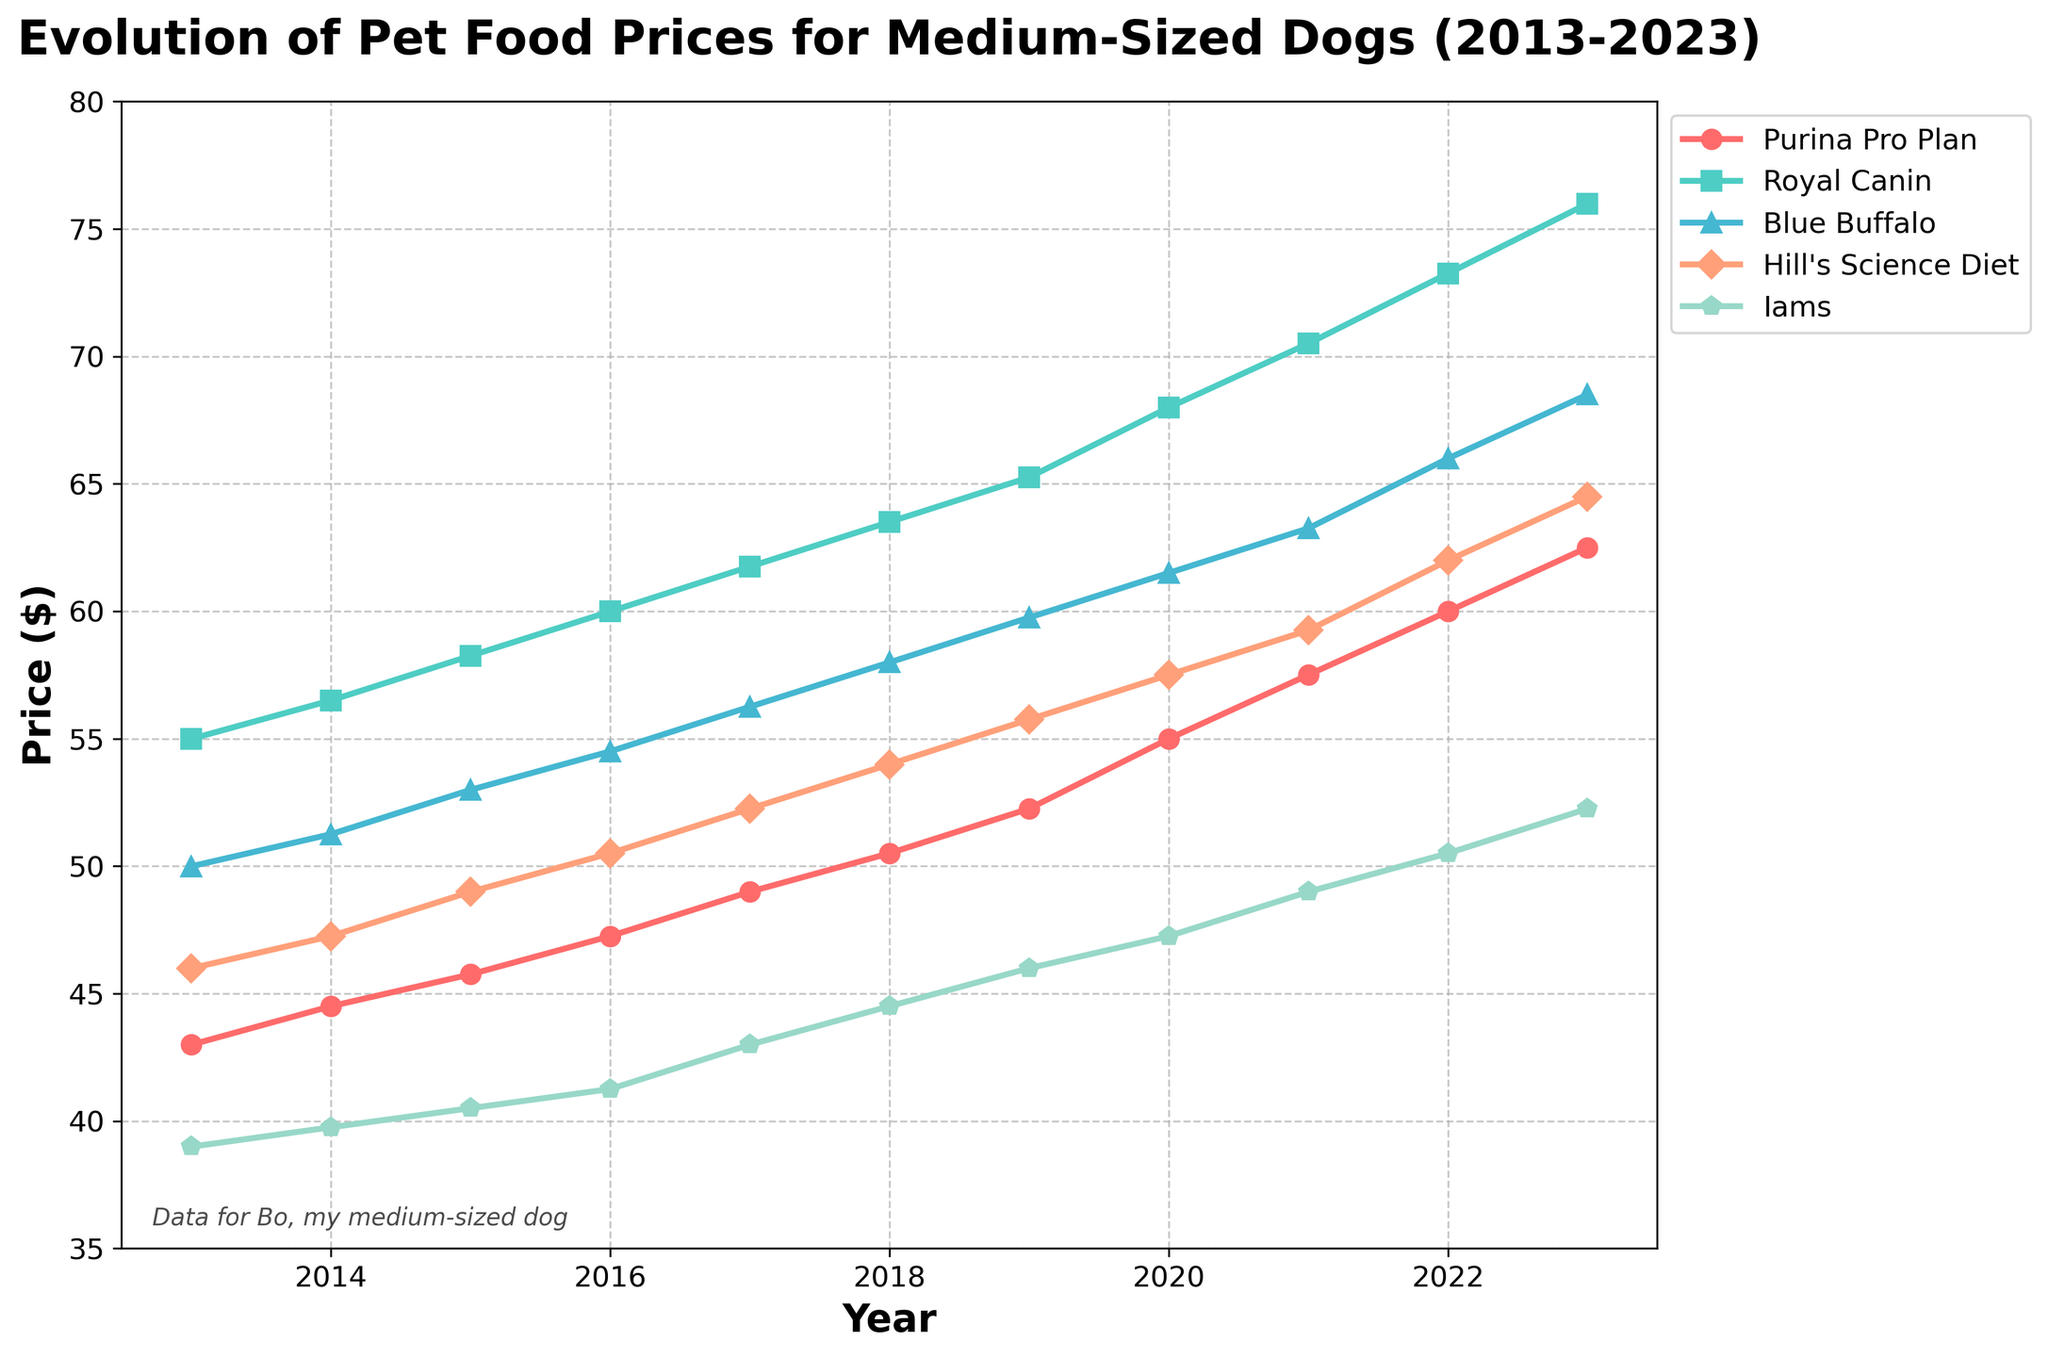What is the overall trend of pet food prices for medium-sized dogs from 2013 to 2023? The overall trend shows a steady increase in the prices of all the pet food brands over the decade. Every line on the chart slopes upward from left to right, indicating that prices have generally risen every year.
Answer: Steady increase Which pet food brand was the most expensive in 2013? To find the most expensive brand in 2013, look at the data points for 2013 on the left side of the chart. The highest data point for 2013 corresponds to Royal Canin.
Answer: Royal Canin In what year did Purina Pro Plan first reach a price higher than $50? Observe the trend line for Purina Pro Plan and identify the year when it crosses the $50 mark. According to the chart, Purina Pro Plan first crosses $50 in 2018.
Answer: 2018 How much did the price of Hill's Science Diet increase from 2013 to 2023? Subtract the price of Hill's Science Diet in 2013 from its price in 2023. The prices are $45.99 in 2013 and $64.50 in 2023. So, the increase is $64.50 - $45.99 = $18.51.
Answer: $18.51 Which two pet food brands' prices in 2023 exhibit the smallest difference, and what is that difference? Compare the prices of all brands in 2023 and find the two that are closest to each other. The prices are Purina Pro Plan ($62.50), Royal Canin ($75.99), Blue Buffalo ($68.50), Hill's Science Diet ($64.50), and Iams ($52.25). The smallest difference is between Hill's Science Diet and Blue Buffalo, which is $68.50 - $64.50 = $4.00.
Answer: Hill's Science Diet and Blue Buffalo, $4.00 Which brand showed the fastest price increase rate over the past decade? To determine the fastest increase, compare the slope of each line from 2013 to 2023. The line for Royal Canin shows the steepest incline, indicating it had the fastest price increase rate.
Answer: Royal Canin What was the average price of Iams pet food over the past decade? Calculate the average price by summing Iams’ prices from 2013 to 2023 and dividing by the number of years. The prices are: (38.99 + 39.75 + 40.50 + 41.25 + 42.99 + 44.50 + 45.99 + 47.25 + 48.99 + 50.50 + 52.25). The sum is 493.96, and the average is 493.96/11 ≈ 44.91.
Answer: $44.91 Which year saw the highest increase in price for Blue Buffalo? Identify the year-to-year differences for Blue Buffalo and determine the largest increase. The largest increase is between 2022 and 2023: $68.50 - $65.99 = $2.51.
Answer: 2022 to 2023 